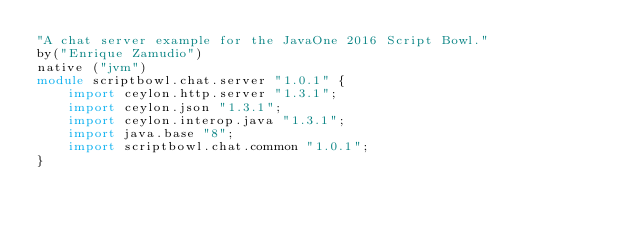<code> <loc_0><loc_0><loc_500><loc_500><_Ceylon_>"A chat server example for the JavaOne 2016 Script Bowl."
by("Enrique Zamudio")
native ("jvm")
module scriptbowl.chat.server "1.0.1" {
    import ceylon.http.server "1.3.1";
    import ceylon.json "1.3.1";
    import ceylon.interop.java "1.3.1";
    import java.base "8";
    import scriptbowl.chat.common "1.0.1";
}
</code> 